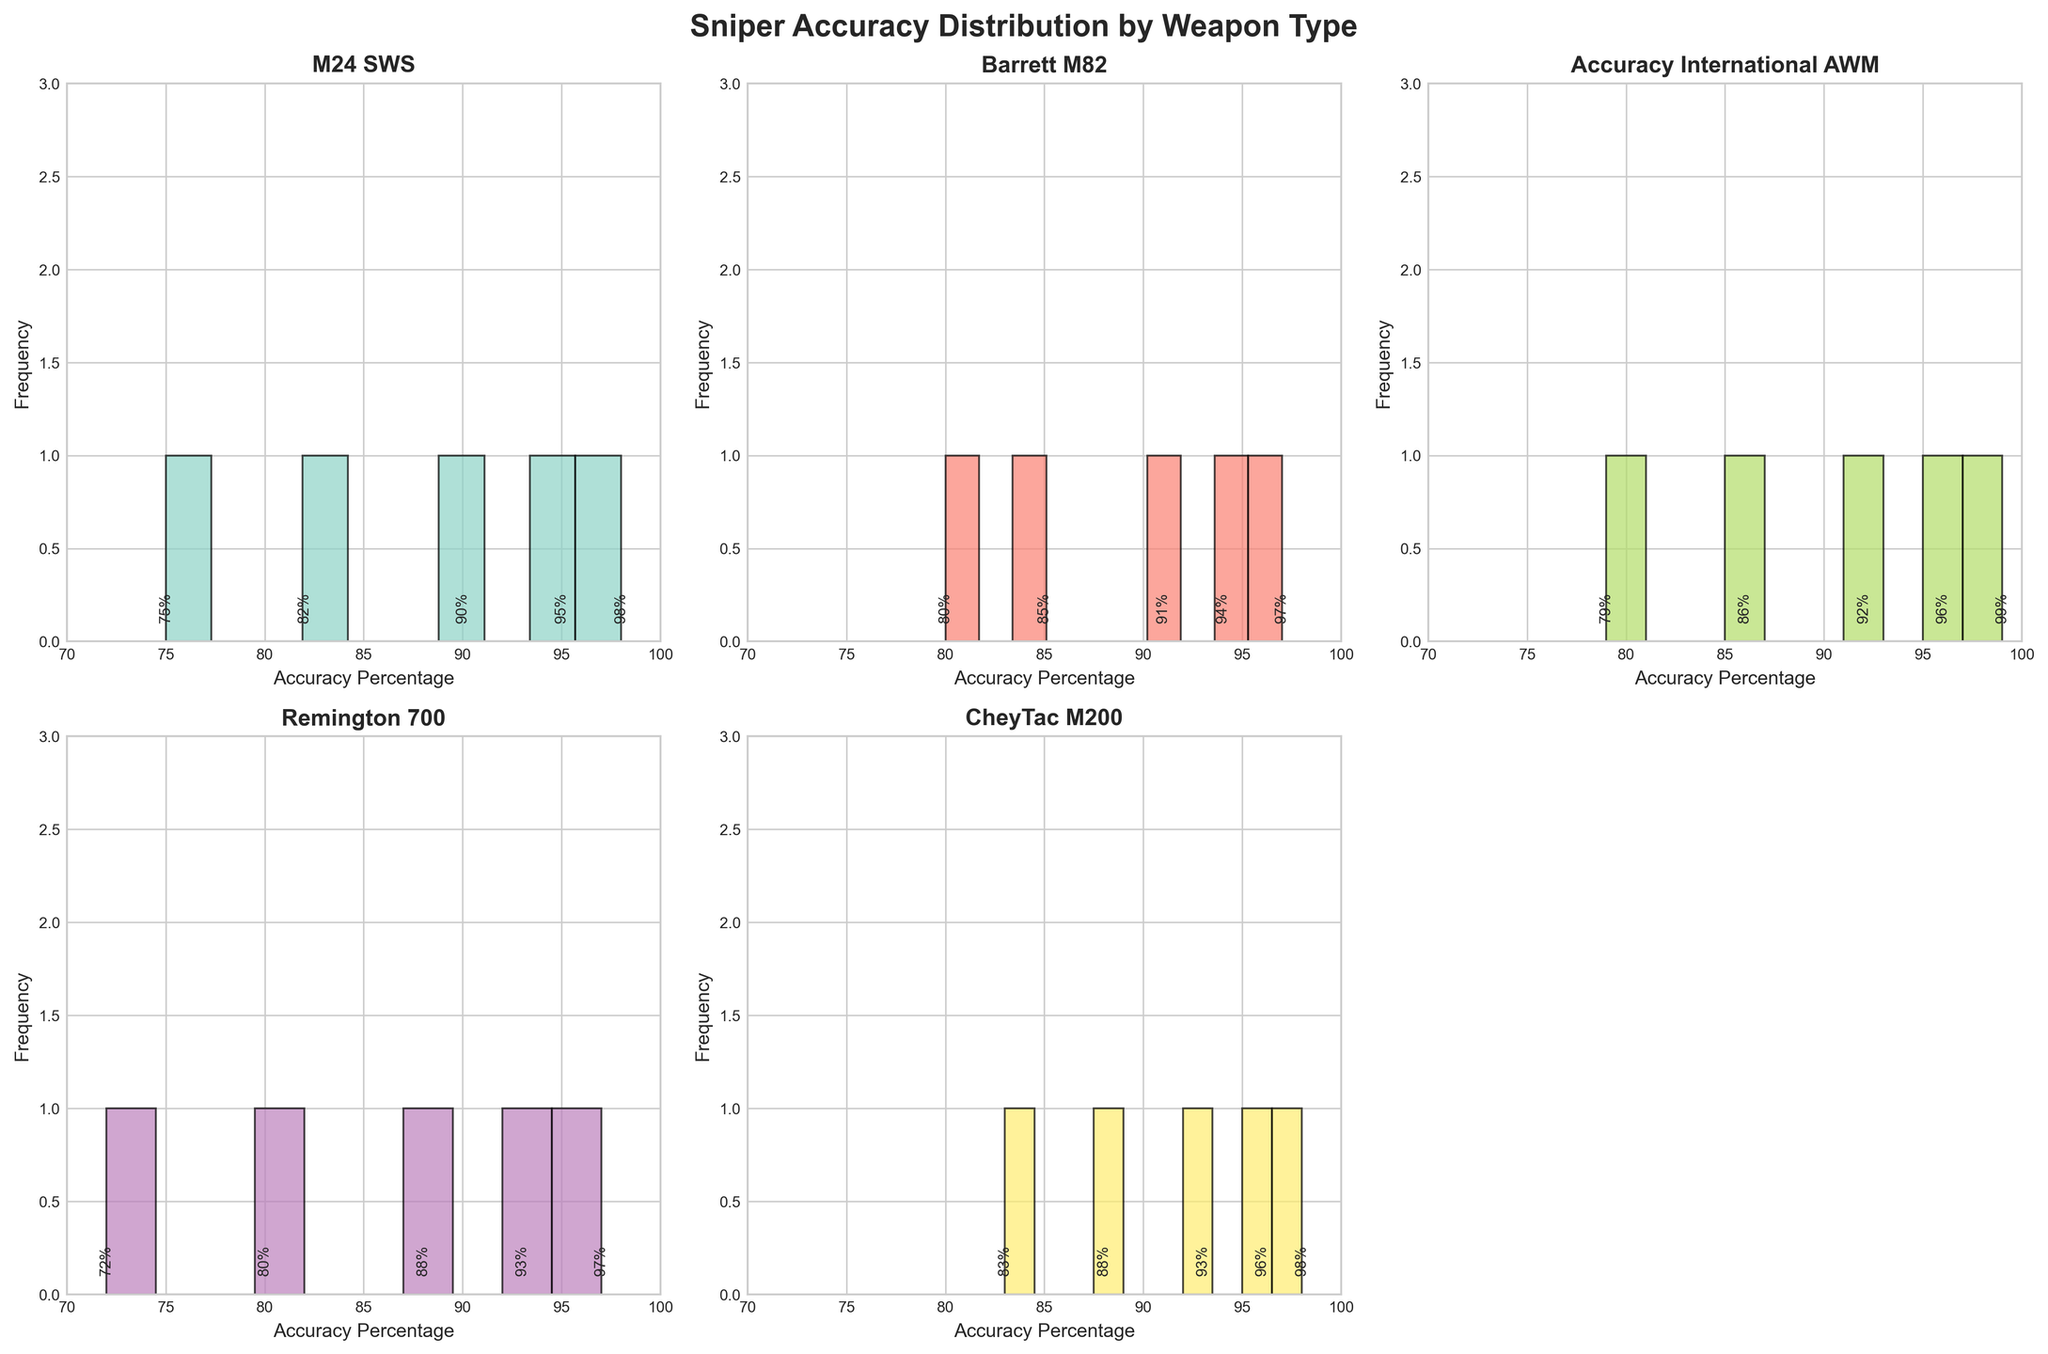How many weapon types are being compared in the figure? There are six subplots, each representing a different weapon type.
Answer: 6 Which weapon has the highest accuracy at 1000 meters? The highest accuracy at 1000 meters can be seen in the subplot titled "Barrett M82" with 80% accuracy.
Answer: Barrett M82 Which two weapons have overlapping accuracy percentages in the 90-100% range? By examining the histograms, "M24 SWS" and "CheyTac M200" both have overlapping percentages of 98% and above.
Answer: M24 SWS and CheyTac M200 Between the "Remington 700" and "Accuracy International AWM," which weapon has a lower accuracy at 800 meters? By comparing the two subplots, the "Remington 700" has an accuracy of 80% at 800 meters, while the "Accuracy International AWM" has 86% accuracy.
Answer: Remington 700 What is the difference in accuracy between "M24 SWS" and "CheyTac M200" at 500 meters? The accuracy of "M24 SWS" at 500 meters is 90%, while for "CheyTac M200" it is 93%. The difference is 93% - 90% = 3%.
Answer: 3% Which weapon shows the most drastic drop in accuracy from 300 meters to 1000 meters? By comparing the histograms, the "Remington 700" drops from 93% at 300 meters to 72% at 1000 meters, which is the most significant drop of 21%.
Answer: Remington 700 How many distinct accuracy percentages are present for the "Accuracy International AWM" weapon? The histogram shows the accuracy percentages for "Accuracy International AWM" as 99%, 96%, 92%, 86%, and 79%. There are no overlaps, so there are five distinct values.
Answer: 5 Which weapon type exhibits a steady decrease in accuracy with increase in distance? By checking all the subplots, each weapon type shows a steady decrease in accuracy as the distance increases, which is consistent across all the weapons.
Answer: All weapons What is the average accuracy percentage of the "Barrett M82" across all distances? The Barrett M82 has accuracy percentages 97%, 94%, 91%, 85%, and 80% across various distances. The average is (97+94+91+85+80)/5 = 89.4%.
Answer: 89.4 Identify the weapon with the least accurate shot at 100 meters. Examining the 100-meter mark in each subplot, the "Barrett M82" has the lowest accuracy with 97%.
Answer: Barrett M82 